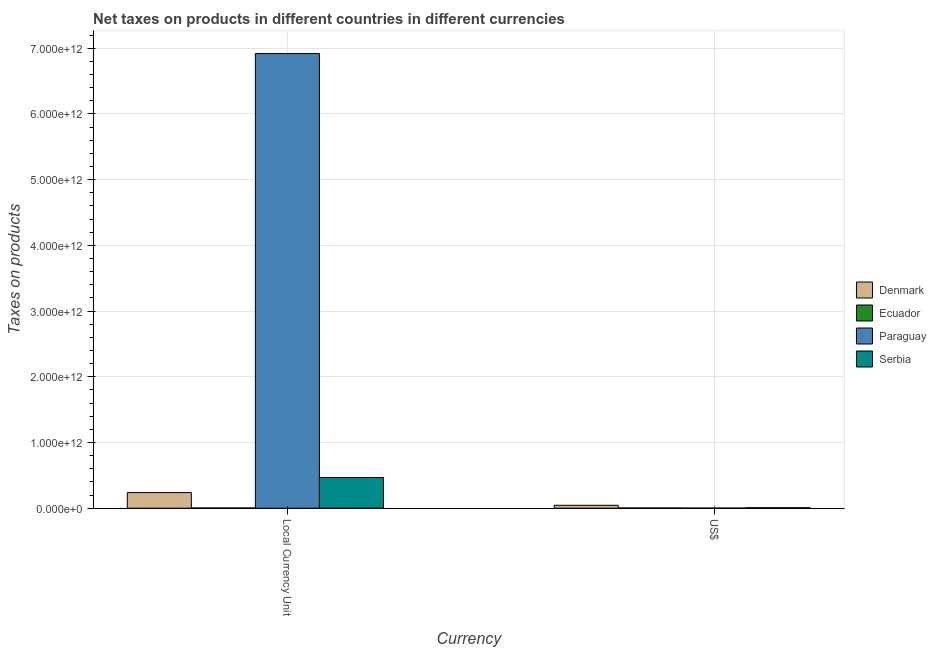How many groups of bars are there?
Your answer should be compact. 2. Are the number of bars per tick equal to the number of legend labels?
Provide a short and direct response. Yes. How many bars are there on the 1st tick from the right?
Provide a short and direct response. 4. What is the label of the 1st group of bars from the left?
Ensure brevity in your answer.  Local Currency Unit. What is the net taxes in us$ in Denmark?
Your response must be concise. 4.42e+1. Across all countries, what is the maximum net taxes in constant 2005 us$?
Offer a terse response. 6.92e+12. Across all countries, what is the minimum net taxes in us$?
Offer a very short reply. 1.39e+09. In which country was the net taxes in constant 2005 us$ minimum?
Give a very brief answer. Ecuador. What is the total net taxes in constant 2005 us$ in the graph?
Provide a succinct answer. 7.63e+12. What is the difference between the net taxes in constant 2005 us$ in Paraguay and that in Denmark?
Your answer should be very brief. 6.68e+12. What is the difference between the net taxes in us$ in Paraguay and the net taxes in constant 2005 us$ in Denmark?
Your answer should be very brief. -2.36e+11. What is the average net taxes in us$ per country?
Offer a terse response. 1.40e+1. What is the difference between the net taxes in us$ and net taxes in constant 2005 us$ in Paraguay?
Your response must be concise. -6.92e+12. In how many countries, is the net taxes in constant 2005 us$ greater than 5000000000000 units?
Give a very brief answer. 1. What is the ratio of the net taxes in constant 2005 us$ in Ecuador to that in Paraguay?
Your answer should be compact. 0. Is the net taxes in constant 2005 us$ in Denmark less than that in Paraguay?
Ensure brevity in your answer.  Yes. What does the 3rd bar from the left in Local Currency Unit represents?
Keep it short and to the point. Paraguay. What does the 1st bar from the right in Local Currency Unit represents?
Make the answer very short. Serbia. How many bars are there?
Make the answer very short. 8. Are all the bars in the graph horizontal?
Your answer should be compact. No. What is the difference between two consecutive major ticks on the Y-axis?
Offer a very short reply. 1.00e+12. Does the graph contain any zero values?
Offer a very short reply. No. How many legend labels are there?
Make the answer very short. 4. What is the title of the graph?
Offer a very short reply. Net taxes on products in different countries in different currencies. What is the label or title of the X-axis?
Ensure brevity in your answer.  Currency. What is the label or title of the Y-axis?
Ensure brevity in your answer.  Taxes on products. What is the Taxes on products of Denmark in Local Currency Unit?
Offer a very short reply. 2.37e+11. What is the Taxes on products of Ecuador in Local Currency Unit?
Ensure brevity in your answer.  3.51e+09. What is the Taxes on products of Paraguay in Local Currency Unit?
Your response must be concise. 6.92e+12. What is the Taxes on products in Serbia in Local Currency Unit?
Provide a succinct answer. 4.67e+11. What is the Taxes on products in Denmark in US$?
Keep it short and to the point. 4.42e+1. What is the Taxes on products of Ecuador in US$?
Offer a very short reply. 3.51e+09. What is the Taxes on products of Paraguay in US$?
Your answer should be very brief. 1.39e+09. What is the Taxes on products of Serbia in US$?
Your answer should be very brief. 6.91e+09. Across all Currency, what is the maximum Taxes on products in Denmark?
Offer a very short reply. 2.37e+11. Across all Currency, what is the maximum Taxes on products of Ecuador?
Provide a succinct answer. 3.51e+09. Across all Currency, what is the maximum Taxes on products in Paraguay?
Provide a succinct answer. 6.92e+12. Across all Currency, what is the maximum Taxes on products in Serbia?
Your answer should be compact. 4.67e+11. Across all Currency, what is the minimum Taxes on products of Denmark?
Your response must be concise. 4.42e+1. Across all Currency, what is the minimum Taxes on products in Ecuador?
Your answer should be very brief. 3.51e+09. Across all Currency, what is the minimum Taxes on products in Paraguay?
Give a very brief answer. 1.39e+09. Across all Currency, what is the minimum Taxes on products in Serbia?
Your response must be concise. 6.91e+09. What is the total Taxes on products in Denmark in the graph?
Provide a short and direct response. 2.81e+11. What is the total Taxes on products in Ecuador in the graph?
Provide a short and direct response. 7.01e+09. What is the total Taxes on products of Paraguay in the graph?
Make the answer very short. 6.92e+12. What is the total Taxes on products of Serbia in the graph?
Offer a very short reply. 4.74e+11. What is the difference between the Taxes on products in Denmark in Local Currency Unit and that in US$?
Keep it short and to the point. 1.93e+11. What is the difference between the Taxes on products of Paraguay in Local Currency Unit and that in US$?
Keep it short and to the point. 6.92e+12. What is the difference between the Taxes on products in Serbia in Local Currency Unit and that in US$?
Ensure brevity in your answer.  4.60e+11. What is the difference between the Taxes on products of Denmark in Local Currency Unit and the Taxes on products of Ecuador in US$?
Give a very brief answer. 2.34e+11. What is the difference between the Taxes on products of Denmark in Local Currency Unit and the Taxes on products of Paraguay in US$?
Offer a terse response. 2.36e+11. What is the difference between the Taxes on products of Denmark in Local Currency Unit and the Taxes on products of Serbia in US$?
Your answer should be very brief. 2.30e+11. What is the difference between the Taxes on products in Ecuador in Local Currency Unit and the Taxes on products in Paraguay in US$?
Give a very brief answer. 2.11e+09. What is the difference between the Taxes on products of Ecuador in Local Currency Unit and the Taxes on products of Serbia in US$?
Your response must be concise. -3.40e+09. What is the difference between the Taxes on products in Paraguay in Local Currency Unit and the Taxes on products in Serbia in US$?
Ensure brevity in your answer.  6.91e+12. What is the average Taxes on products of Denmark per Currency?
Give a very brief answer. 1.41e+11. What is the average Taxes on products in Ecuador per Currency?
Keep it short and to the point. 3.51e+09. What is the average Taxes on products of Paraguay per Currency?
Provide a succinct answer. 3.46e+12. What is the average Taxes on products of Serbia per Currency?
Offer a terse response. 2.37e+11. What is the difference between the Taxes on products of Denmark and Taxes on products of Ecuador in Local Currency Unit?
Keep it short and to the point. 2.34e+11. What is the difference between the Taxes on products of Denmark and Taxes on products of Paraguay in Local Currency Unit?
Your answer should be compact. -6.68e+12. What is the difference between the Taxes on products of Denmark and Taxes on products of Serbia in Local Currency Unit?
Your answer should be compact. -2.30e+11. What is the difference between the Taxes on products in Ecuador and Taxes on products in Paraguay in Local Currency Unit?
Keep it short and to the point. -6.92e+12. What is the difference between the Taxes on products in Ecuador and Taxes on products in Serbia in Local Currency Unit?
Provide a short and direct response. -4.64e+11. What is the difference between the Taxes on products of Paraguay and Taxes on products of Serbia in Local Currency Unit?
Offer a very short reply. 6.45e+12. What is the difference between the Taxes on products of Denmark and Taxes on products of Ecuador in US$?
Your answer should be very brief. 4.07e+1. What is the difference between the Taxes on products in Denmark and Taxes on products in Paraguay in US$?
Provide a succinct answer. 4.29e+1. What is the difference between the Taxes on products of Denmark and Taxes on products of Serbia in US$?
Your answer should be compact. 3.73e+1. What is the difference between the Taxes on products in Ecuador and Taxes on products in Paraguay in US$?
Your answer should be compact. 2.11e+09. What is the difference between the Taxes on products of Ecuador and Taxes on products of Serbia in US$?
Your response must be concise. -3.40e+09. What is the difference between the Taxes on products of Paraguay and Taxes on products of Serbia in US$?
Provide a short and direct response. -5.52e+09. What is the ratio of the Taxes on products in Denmark in Local Currency Unit to that in US$?
Ensure brevity in your answer.  5.36. What is the ratio of the Taxes on products of Ecuador in Local Currency Unit to that in US$?
Your response must be concise. 1. What is the ratio of the Taxes on products in Paraguay in Local Currency Unit to that in US$?
Provide a succinct answer. 4966.58. What is the ratio of the Taxes on products of Serbia in Local Currency Unit to that in US$?
Ensure brevity in your answer.  67.58. What is the difference between the highest and the second highest Taxes on products in Denmark?
Your answer should be compact. 1.93e+11. What is the difference between the highest and the second highest Taxes on products of Ecuador?
Provide a succinct answer. 0. What is the difference between the highest and the second highest Taxes on products of Paraguay?
Offer a terse response. 6.92e+12. What is the difference between the highest and the second highest Taxes on products of Serbia?
Give a very brief answer. 4.60e+11. What is the difference between the highest and the lowest Taxes on products of Denmark?
Make the answer very short. 1.93e+11. What is the difference between the highest and the lowest Taxes on products in Ecuador?
Your answer should be very brief. 0. What is the difference between the highest and the lowest Taxes on products of Paraguay?
Your answer should be very brief. 6.92e+12. What is the difference between the highest and the lowest Taxes on products in Serbia?
Give a very brief answer. 4.60e+11. 